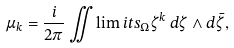<formula> <loc_0><loc_0><loc_500><loc_500>\mu _ { k } = \frac { i } { 2 \pi } \iint \lim i t s _ { \Omega } \zeta ^ { k } \, d \zeta \wedge d \bar { \zeta } ,</formula> 